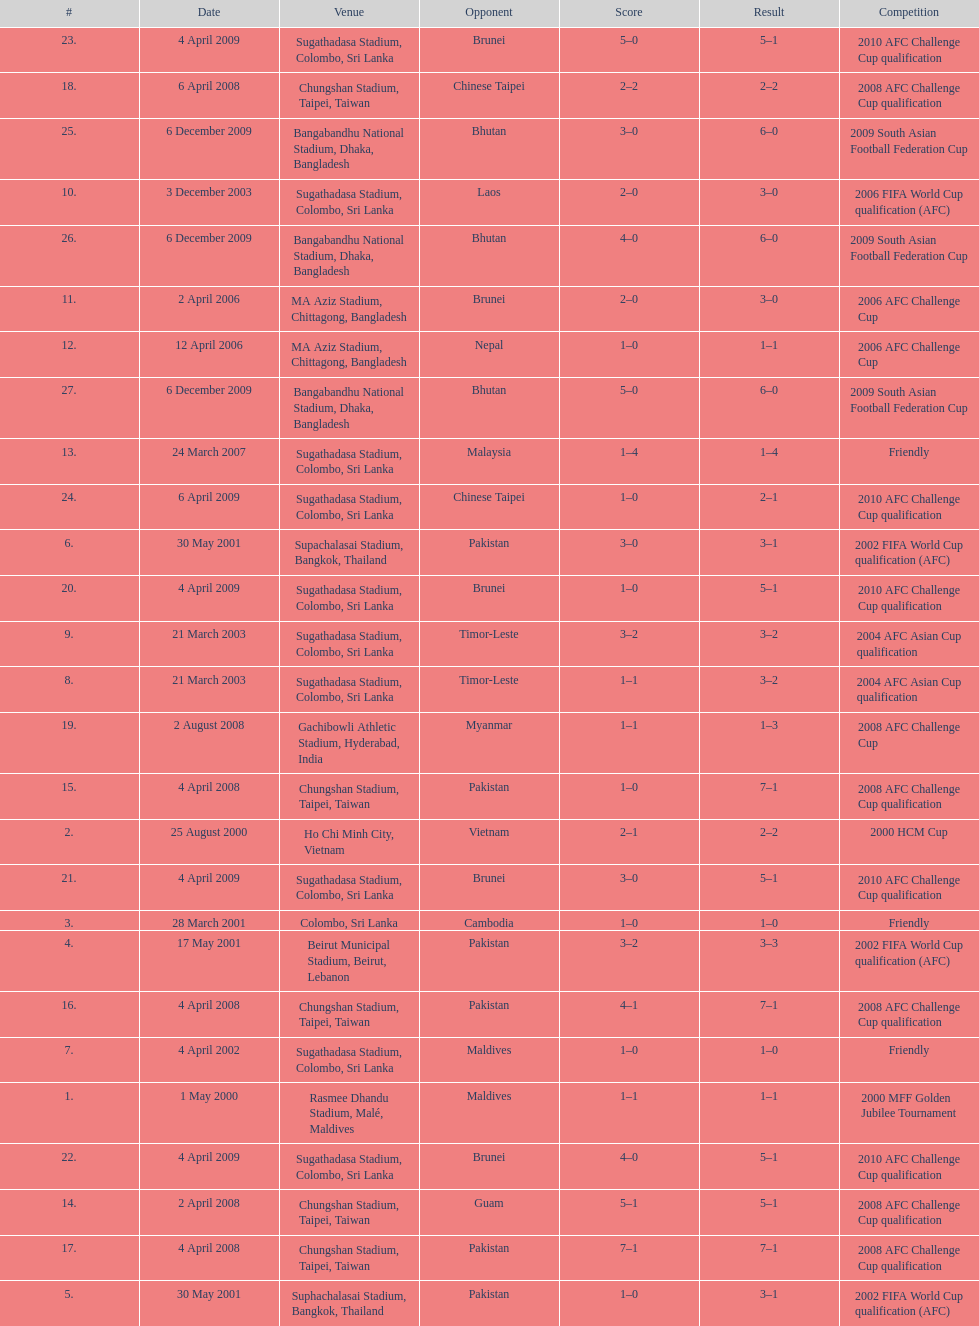What is the top listed venue in the table? Rasmee Dhandu Stadium, Malé, Maldives. 